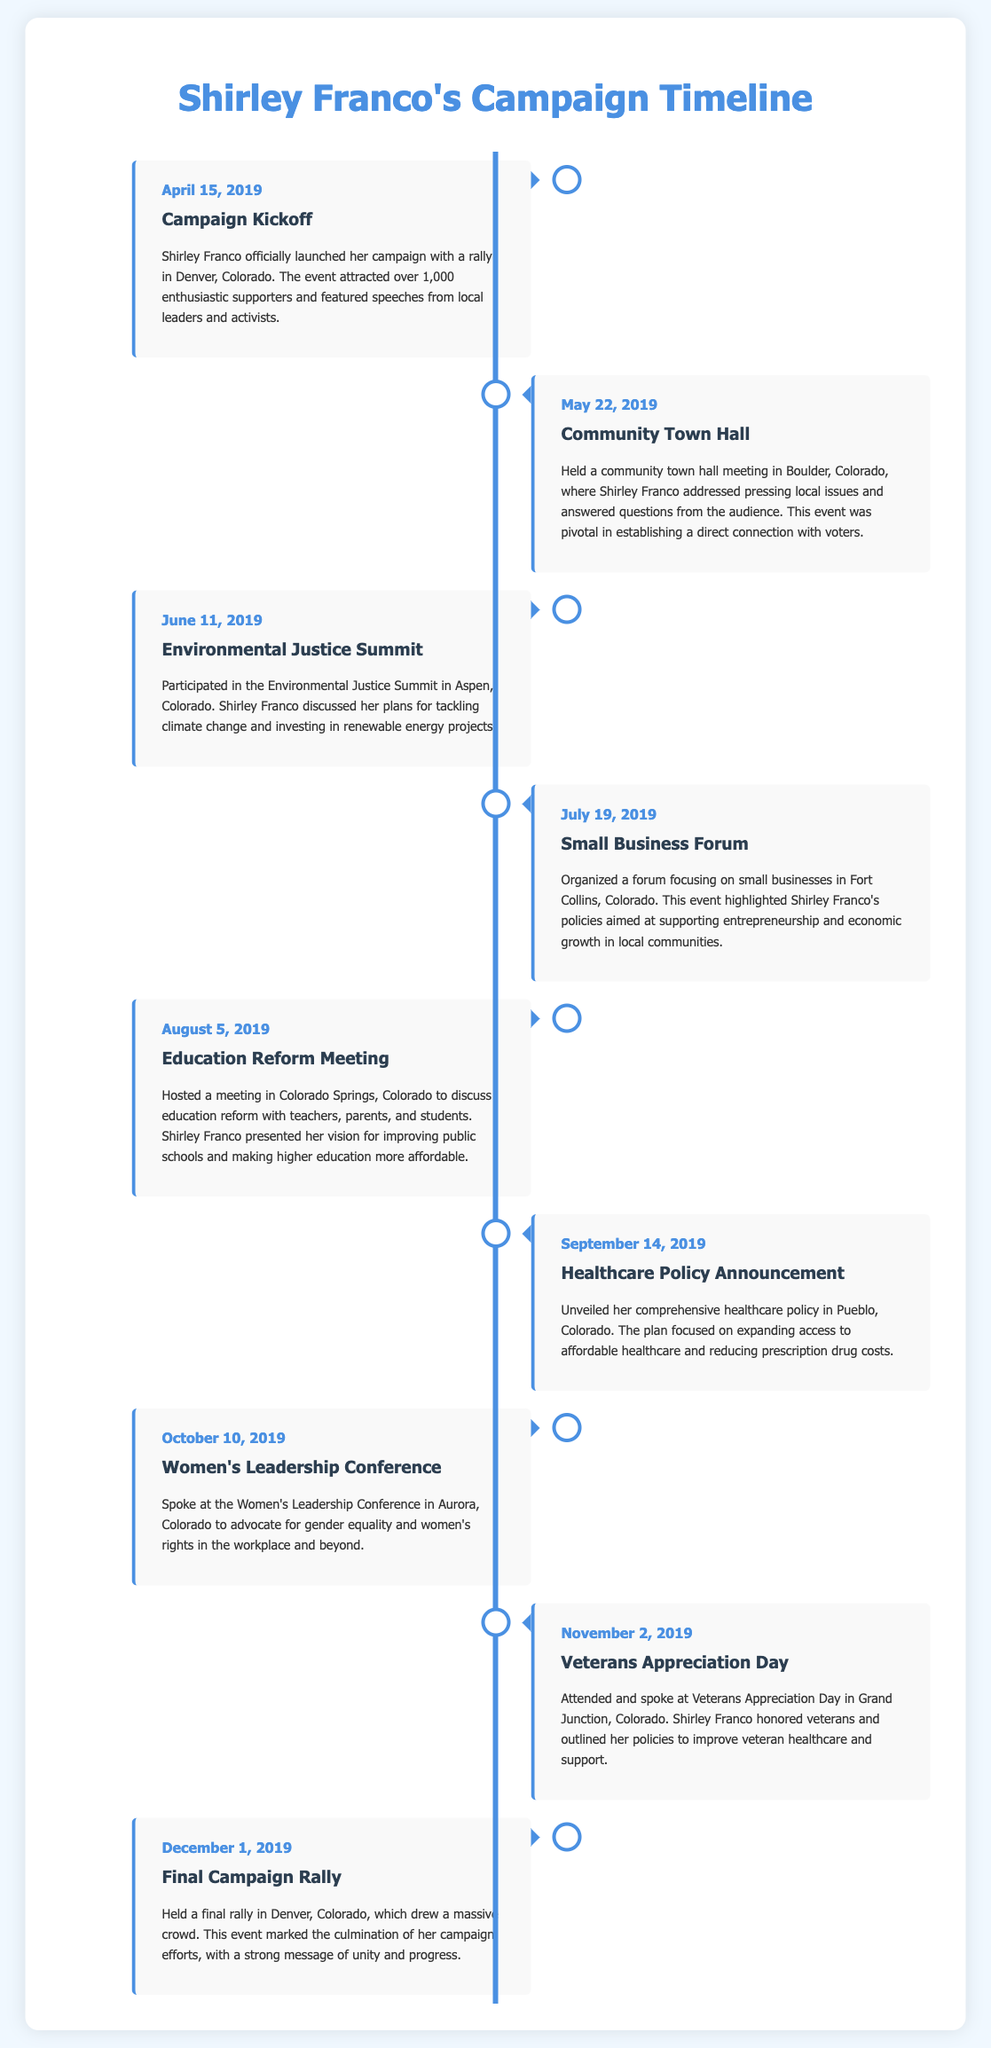What date did Shirley Franco officially launch her campaign? The document states that the campaign was officially launched on April 15, 2019.
Answer: April 15, 2019 What city hosted the first community town hall meeting? The community town hall meeting was held in Boulder, Colorado.
Answer: Boulder, Colorado What was the main focus of the Environmental Justice Summit? Shirley Franco discussed her plans for tackling climate change and investing in renewable energy projects at the summit.
Answer: Tackling climate change How many events are documented in the timeline? The timeline includes a total of eight key campaign events and engagements.
Answer: Eight What theme did Shirley Franco advocate for at the Women's Leadership Conference? At the Women's Leadership Conference, she advocated for gender equality and women's rights.
Answer: Gender equality Which event showed Shirley Franco's commitment to veterans? The event honoring veterans was the Veterans Appreciation Day in Grand Junction, Colorado.
Answer: Veterans Appreciation Day When was the final campaign rally held? The date of the final campaign rally is December 1, 2019.
Answer: December 1, 2019 What type of event took place on July 19, 2019? The event organized was a forum focusing on small businesses.
Answer: Small Business Forum In which city did Shirley Franco unveil her healthcare policy? The healthcare policy was announced in Pueblo, Colorado.
Answer: Pueblo, Colorado 